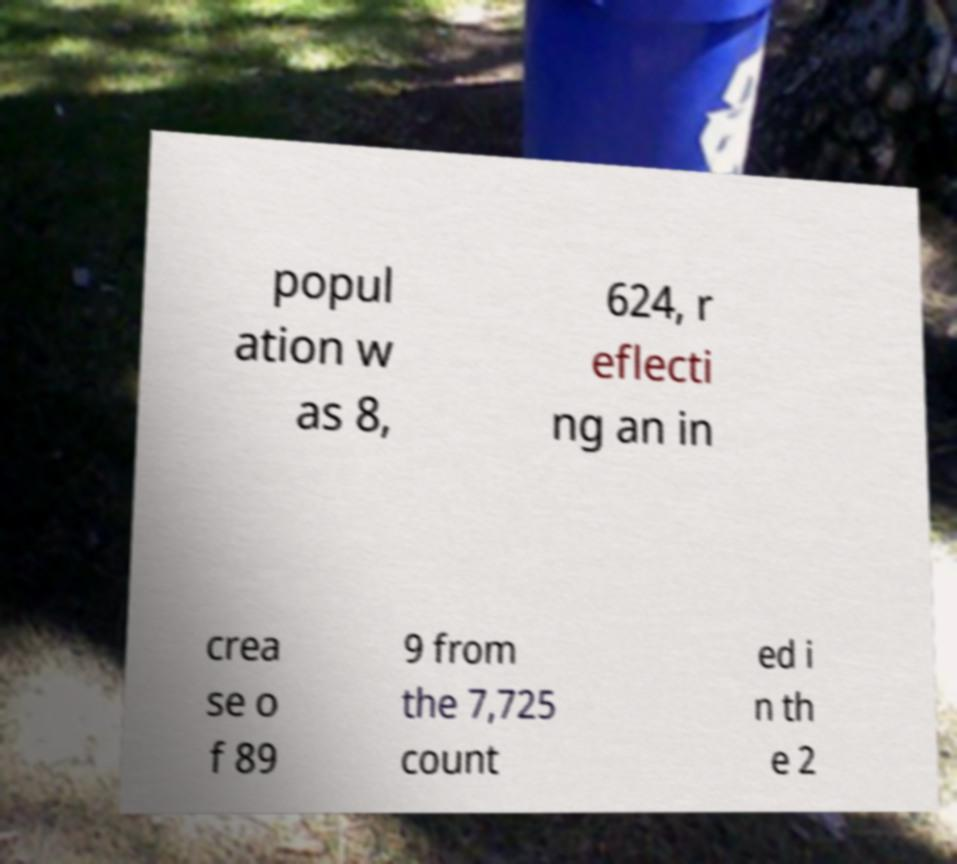There's text embedded in this image that I need extracted. Can you transcribe it verbatim? popul ation w as 8, 624, r eflecti ng an in crea se o f 89 9 from the 7,725 count ed i n th e 2 